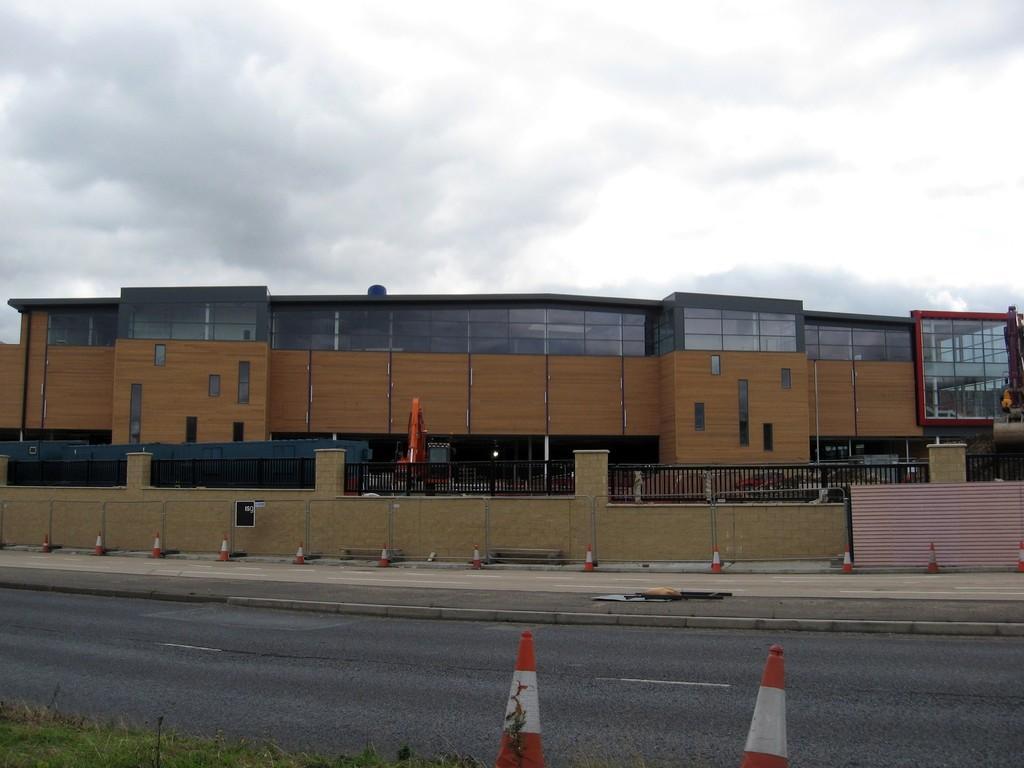Describe this image in one or two sentences. This image is taken outdoors. At the top of the image there is the sky with clouds. At the bottom of the image there is a ground with grass on it and there is a road. There are two safety cones on the road. In the middle of the image there is a building with wall, windows, doors and a roof. There is a railing and there is a wall. There are a few safety cones on the sidewalk. 